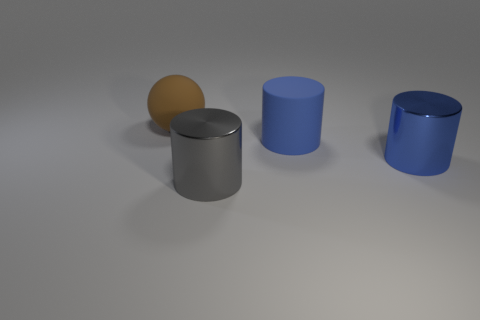Can you describe the lighting in the scene? The lighting in the image is soft and diffused, appearing to come from a source above the objects, casting slight shadows directly beneath them. This gives the objects a gentle illumination and a clear definition. 